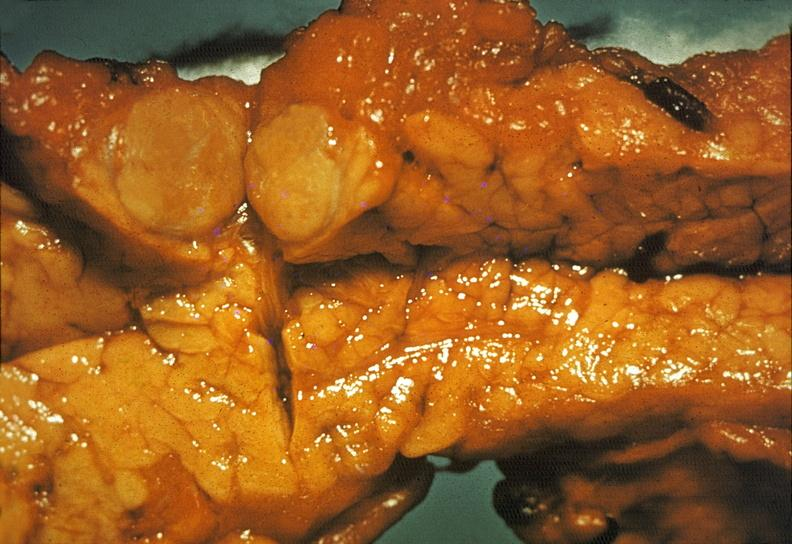s fractures brain which is slide and close-up view of these fractures present?
Answer the question using a single word or phrase. No 